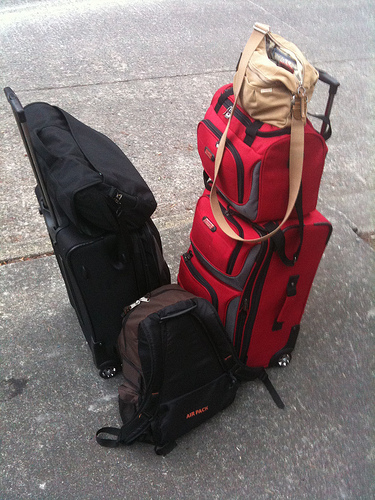Please provide a short description for this region: [0.65, 0.07, 0.73, 0.16]. Displayed is an unzipped purse, light-colored and placed casually atop a heap, indicating a rushed or unpacking moment. 